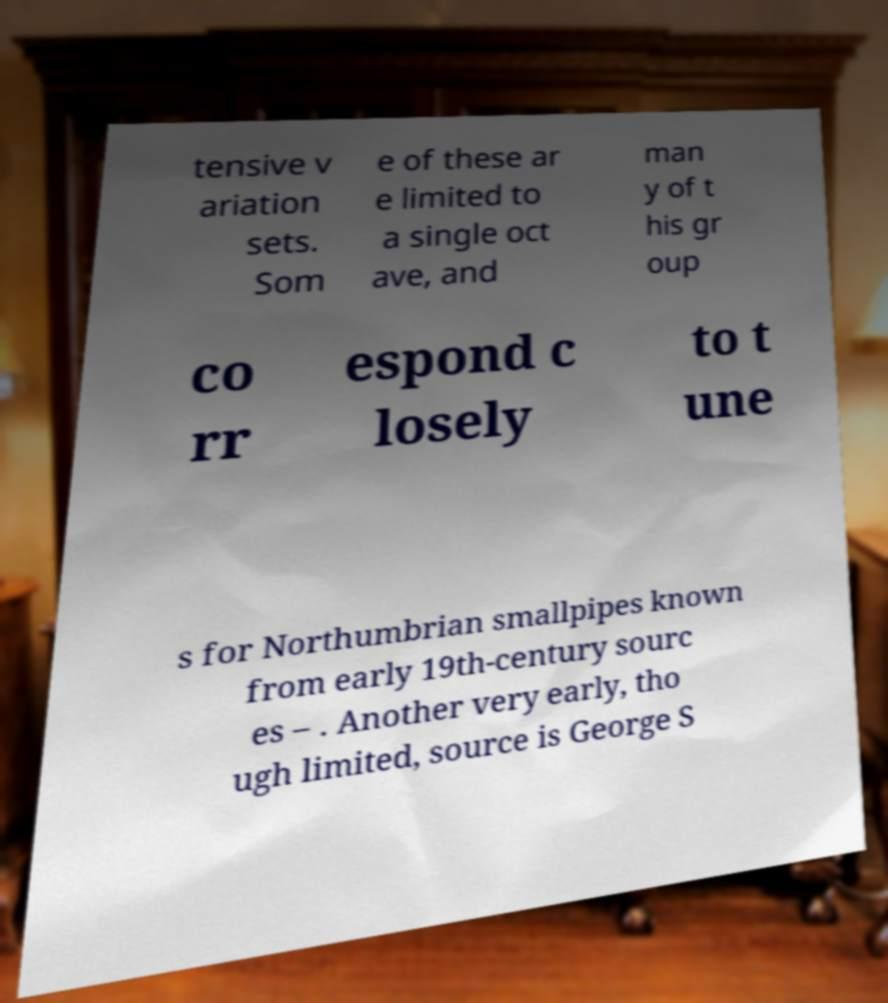For documentation purposes, I need the text within this image transcribed. Could you provide that? tensive v ariation sets. Som e of these ar e limited to a single oct ave, and man y of t his gr oup co rr espond c losely to t une s for Northumbrian smallpipes known from early 19th-century sourc es – . Another very early, tho ugh limited, source is George S 